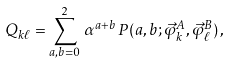<formula> <loc_0><loc_0><loc_500><loc_500>Q _ { k \ell } = \sum _ { a , b = 0 } ^ { 2 } \, \alpha ^ { a + b } \, P ( a , b ; \vec { \varphi } ^ { A } _ { k } , \vec { \varphi } ^ { B } _ { \ell } ) \, ,</formula> 